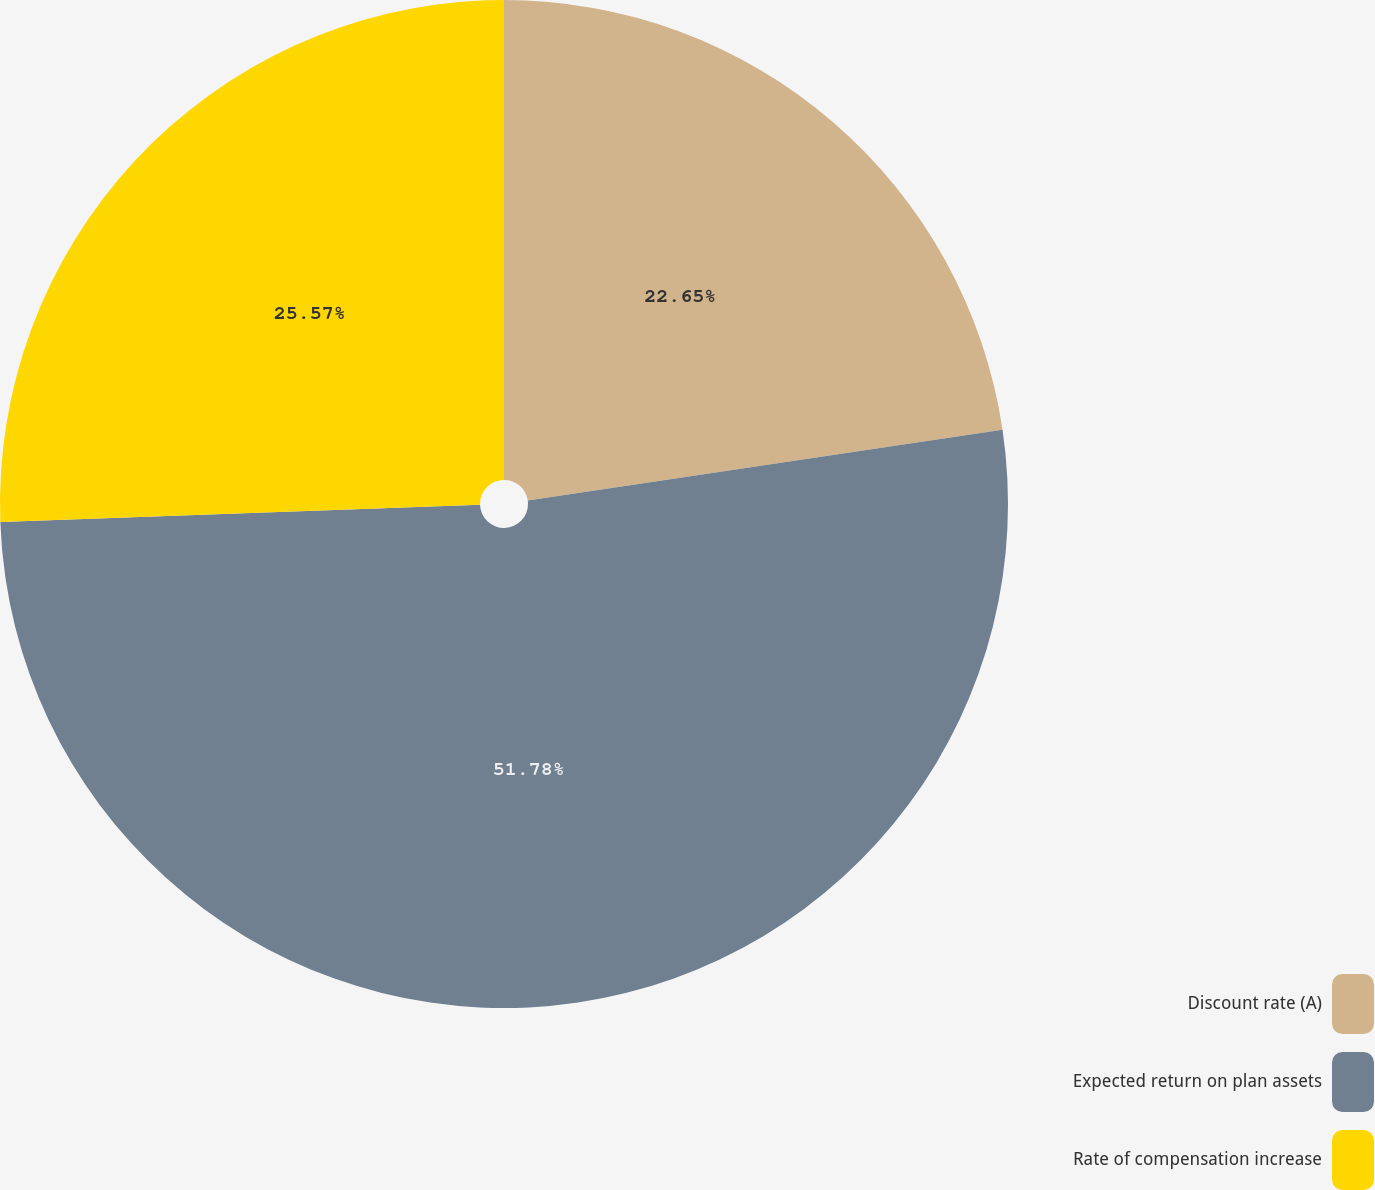Convert chart to OTSL. <chart><loc_0><loc_0><loc_500><loc_500><pie_chart><fcel>Discount rate (A)<fcel>Expected return on plan assets<fcel>Rate of compensation increase<nl><fcel>22.65%<fcel>51.78%<fcel>25.57%<nl></chart> 